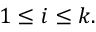Convert formula to latex. <formula><loc_0><loc_0><loc_500><loc_500>1 \leq i \leq k .</formula> 